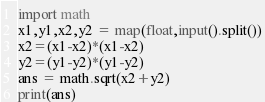<code> <loc_0><loc_0><loc_500><loc_500><_Python_>import math
x1,y1,x2,y2 = map(float,input().split())
x2=(x1-x2)*(x1-x2)
y2=(y1-y2)*(y1-y2)
ans = math.sqrt(x2+y2)
print(ans)
</code> 